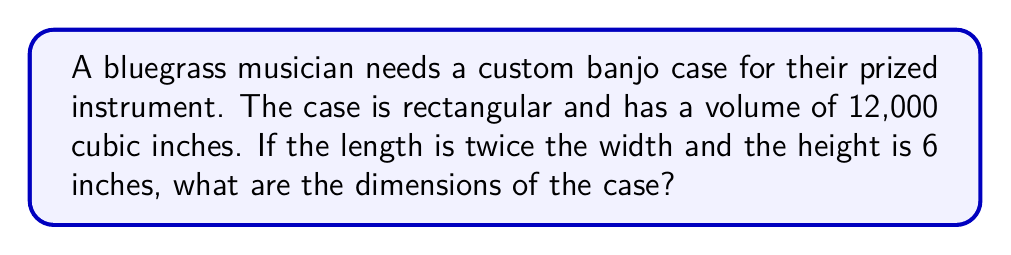What is the answer to this math problem? Let's approach this step-by-step:

1) Let $w$ be the width of the case. Given information:
   - Length = $2w$
   - Height = 6 inches
   - Volume = 12,000 cubic inches

2) The volume of a rectangular prism is given by length × width × height. We can express this as an equation:

   $$(2w) \times w \times 6 = 12000$$

3) Simplify the left side of the equation:

   $$12w^2 = 12000$$

4) Divide both sides by 12:

   $$w^2 = 1000$$

5) Take the square root of both sides:

   $$w = \sqrt{1000} = 10\sqrt{10} \approx 31.62$$

6) Since we're dealing with physical dimensions, we'll round to the nearest inch:
   
   Width $\approx 32$ inches

7) Now we can calculate the length:
   
   Length = $2w \approx 2 \times 32 = 64$ inches

Therefore, the dimensions are approximately:
- Width: 32 inches
- Length: 64 inches
- Height: 6 inches
Answer: $32" \times 64" \times 6"$ 